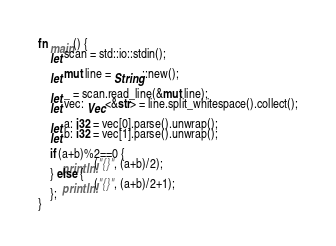Convert code to text. <code><loc_0><loc_0><loc_500><loc_500><_Rust_>fn main() {
    let scan = std::io::stdin();
    
    let mut line = String::new();

    let _ = scan.read_line(&mut line);
    let vec: Vec<&str> = line.split_whitespace().collect();

    let a: i32 = vec[0].parse().unwrap();
    let b: i32 = vec[1].parse().unwrap();

    if (a+b)%2==0 {
        println!("{}", (a+b)/2);
    } else {
        println!("{}", (a+b)/2+1);
    };
}</code> 